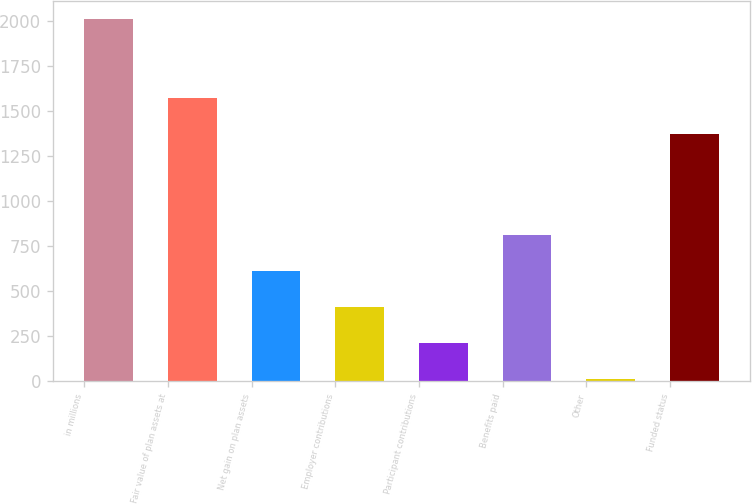<chart> <loc_0><loc_0><loc_500><loc_500><bar_chart><fcel>in millions<fcel>Fair value of plan assets at<fcel>Net gain on plan assets<fcel>Employer contributions<fcel>Participant contributions<fcel>Benefits paid<fcel>Other<fcel>Funded status<nl><fcel>2014<fcel>1575.4<fcel>612.6<fcel>412.4<fcel>212.2<fcel>812.8<fcel>12<fcel>1375.2<nl></chart> 